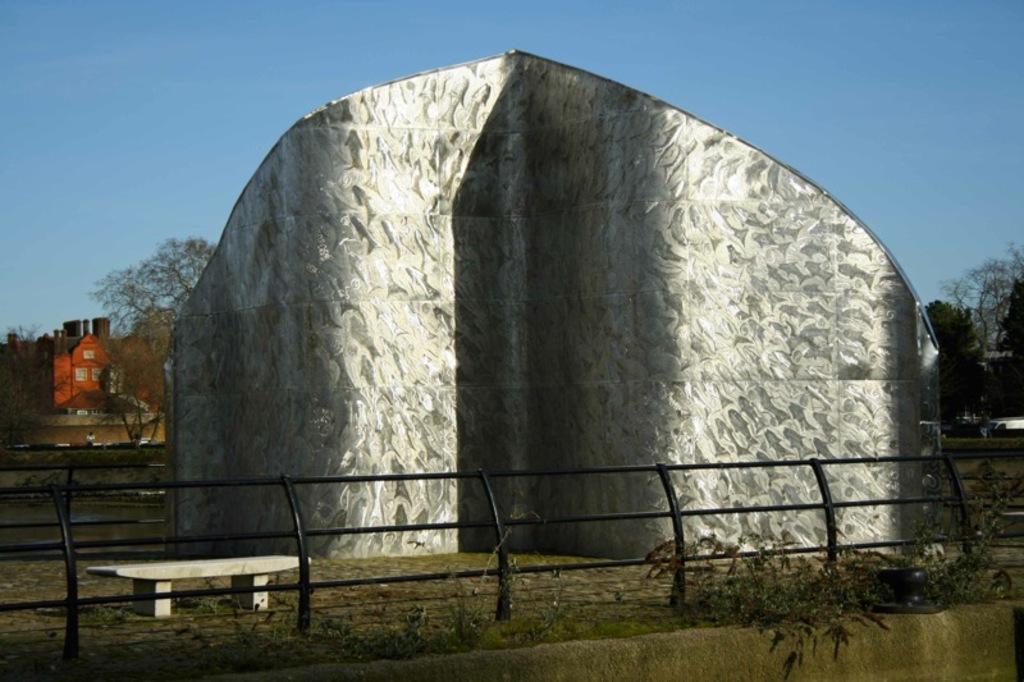Could you give a brief overview of what you see in this image? In this image I can see an architecture in white color. In front I can see the bench and the railing, background I can see few trees in green color, few buildings and the sky is in blue color. 